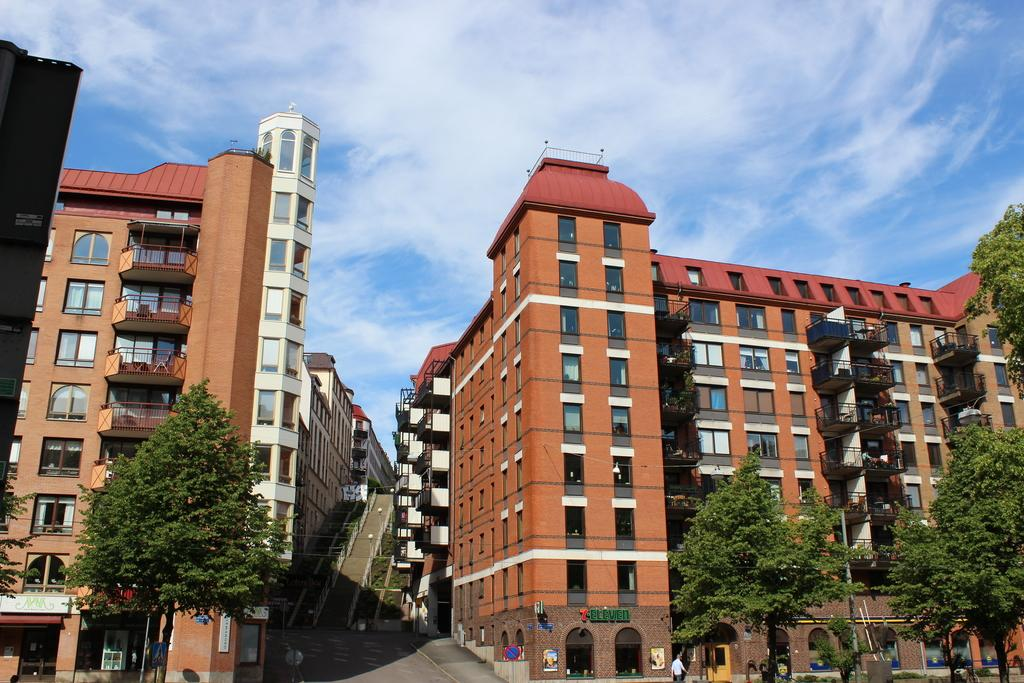What type of natural elements can be seen in the image? There are trees in the image. What type of man-made structures are present in the image? There are buildings in the image. What is located in the middle of the building? There is a road and steps in the middle of the building. What is visible in the background of the image? The sky is visible in the background of the image. What type of toys can be seen on the mountain in the image? There is no mountain or toys present in the image. What suggestion does the image give for improving the area? The image does not provide any suggestions for improving the area; it simply depicts the scene as it is. 